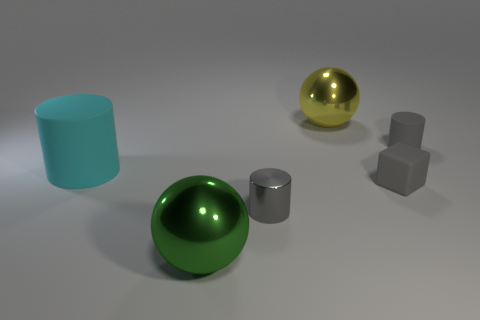Add 1 green matte cylinders. How many objects exist? 7 Subtract all cubes. How many objects are left? 5 Add 5 tiny cyan metallic cubes. How many tiny cyan metallic cubes exist? 5 Subtract 0 green cubes. How many objects are left? 6 Subtract all gray rubber cylinders. Subtract all small things. How many objects are left? 2 Add 5 metal cylinders. How many metal cylinders are left? 6 